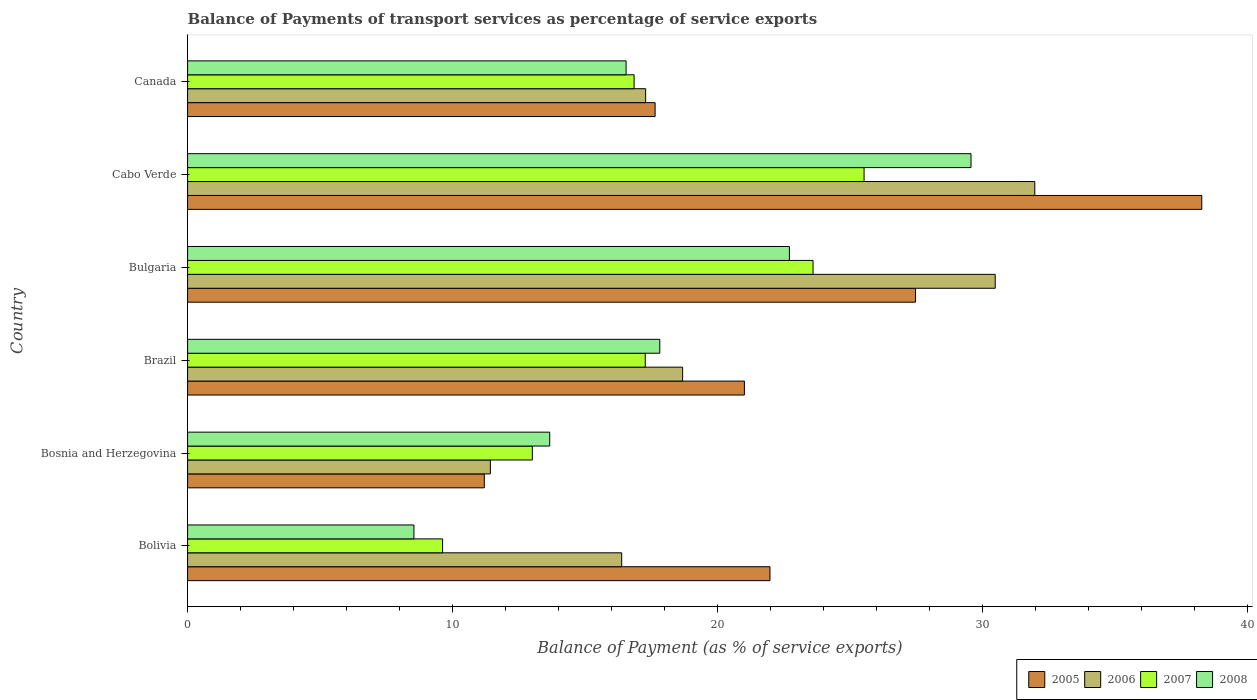Are the number of bars per tick equal to the number of legend labels?
Make the answer very short. Yes. How many bars are there on the 3rd tick from the bottom?
Your answer should be very brief. 4. What is the label of the 5th group of bars from the top?
Provide a short and direct response. Bosnia and Herzegovina. What is the balance of payments of transport services in 2008 in Bolivia?
Make the answer very short. 8.54. Across all countries, what is the maximum balance of payments of transport services in 2006?
Offer a very short reply. 31.97. Across all countries, what is the minimum balance of payments of transport services in 2007?
Provide a short and direct response. 9.62. In which country was the balance of payments of transport services in 2005 maximum?
Give a very brief answer. Cabo Verde. In which country was the balance of payments of transport services in 2006 minimum?
Your answer should be very brief. Bosnia and Herzegovina. What is the total balance of payments of transport services in 2007 in the graph?
Your response must be concise. 105.87. What is the difference between the balance of payments of transport services in 2007 in Bolivia and that in Bosnia and Herzegovina?
Your answer should be very brief. -3.39. What is the difference between the balance of payments of transport services in 2008 in Cabo Verde and the balance of payments of transport services in 2006 in Bosnia and Herzegovina?
Your answer should be compact. 18.14. What is the average balance of payments of transport services in 2006 per country?
Your answer should be very brief. 21.03. What is the difference between the balance of payments of transport services in 2005 and balance of payments of transport services in 2008 in Cabo Verde?
Provide a short and direct response. 8.71. In how many countries, is the balance of payments of transport services in 2007 greater than 14 %?
Your answer should be very brief. 4. What is the ratio of the balance of payments of transport services in 2008 in Bolivia to that in Canada?
Your answer should be very brief. 0.52. Is the balance of payments of transport services in 2008 in Brazil less than that in Cabo Verde?
Your response must be concise. Yes. Is the difference between the balance of payments of transport services in 2005 in Bosnia and Herzegovina and Canada greater than the difference between the balance of payments of transport services in 2008 in Bosnia and Herzegovina and Canada?
Ensure brevity in your answer.  No. What is the difference between the highest and the second highest balance of payments of transport services in 2005?
Your answer should be very brief. 10.8. What is the difference between the highest and the lowest balance of payments of transport services in 2005?
Ensure brevity in your answer.  27.07. Is it the case that in every country, the sum of the balance of payments of transport services in 2007 and balance of payments of transport services in 2006 is greater than the sum of balance of payments of transport services in 2008 and balance of payments of transport services in 2005?
Ensure brevity in your answer.  No. What is the difference between two consecutive major ticks on the X-axis?
Offer a terse response. 10. Are the values on the major ticks of X-axis written in scientific E-notation?
Ensure brevity in your answer.  No. Where does the legend appear in the graph?
Give a very brief answer. Bottom right. How many legend labels are there?
Ensure brevity in your answer.  4. What is the title of the graph?
Make the answer very short. Balance of Payments of transport services as percentage of service exports. Does "1972" appear as one of the legend labels in the graph?
Your answer should be compact. No. What is the label or title of the X-axis?
Provide a short and direct response. Balance of Payment (as % of service exports). What is the Balance of Payment (as % of service exports) in 2005 in Bolivia?
Offer a very short reply. 21.97. What is the Balance of Payment (as % of service exports) of 2006 in Bolivia?
Your answer should be very brief. 16.38. What is the Balance of Payment (as % of service exports) of 2007 in Bolivia?
Your answer should be very brief. 9.62. What is the Balance of Payment (as % of service exports) of 2008 in Bolivia?
Provide a succinct answer. 8.54. What is the Balance of Payment (as % of service exports) of 2005 in Bosnia and Herzegovina?
Keep it short and to the point. 11.19. What is the Balance of Payment (as % of service exports) of 2006 in Bosnia and Herzegovina?
Provide a succinct answer. 11.42. What is the Balance of Payment (as % of service exports) of 2007 in Bosnia and Herzegovina?
Offer a terse response. 13.01. What is the Balance of Payment (as % of service exports) in 2008 in Bosnia and Herzegovina?
Make the answer very short. 13.66. What is the Balance of Payment (as % of service exports) in 2005 in Brazil?
Offer a very short reply. 21.01. What is the Balance of Payment (as % of service exports) in 2006 in Brazil?
Your answer should be very brief. 18.68. What is the Balance of Payment (as % of service exports) in 2007 in Brazil?
Provide a short and direct response. 17.27. What is the Balance of Payment (as % of service exports) in 2008 in Brazil?
Your answer should be very brief. 17.82. What is the Balance of Payment (as % of service exports) in 2005 in Bulgaria?
Provide a short and direct response. 27.47. What is the Balance of Payment (as % of service exports) in 2006 in Bulgaria?
Your response must be concise. 30.47. What is the Balance of Payment (as % of service exports) in 2007 in Bulgaria?
Your response must be concise. 23.6. What is the Balance of Payment (as % of service exports) of 2008 in Bulgaria?
Offer a terse response. 22.71. What is the Balance of Payment (as % of service exports) in 2005 in Cabo Verde?
Your answer should be compact. 38.27. What is the Balance of Payment (as % of service exports) of 2006 in Cabo Verde?
Give a very brief answer. 31.97. What is the Balance of Payment (as % of service exports) of 2007 in Cabo Verde?
Give a very brief answer. 25.53. What is the Balance of Payment (as % of service exports) in 2008 in Cabo Verde?
Provide a succinct answer. 29.56. What is the Balance of Payment (as % of service exports) in 2005 in Canada?
Make the answer very short. 17.64. What is the Balance of Payment (as % of service exports) of 2006 in Canada?
Give a very brief answer. 17.28. What is the Balance of Payment (as % of service exports) of 2007 in Canada?
Offer a very short reply. 16.85. What is the Balance of Payment (as % of service exports) in 2008 in Canada?
Give a very brief answer. 16.55. Across all countries, what is the maximum Balance of Payment (as % of service exports) of 2005?
Your answer should be compact. 38.27. Across all countries, what is the maximum Balance of Payment (as % of service exports) of 2006?
Provide a short and direct response. 31.97. Across all countries, what is the maximum Balance of Payment (as % of service exports) of 2007?
Your answer should be compact. 25.53. Across all countries, what is the maximum Balance of Payment (as % of service exports) in 2008?
Provide a short and direct response. 29.56. Across all countries, what is the minimum Balance of Payment (as % of service exports) in 2005?
Give a very brief answer. 11.19. Across all countries, what is the minimum Balance of Payment (as % of service exports) in 2006?
Provide a short and direct response. 11.42. Across all countries, what is the minimum Balance of Payment (as % of service exports) in 2007?
Your answer should be very brief. 9.62. Across all countries, what is the minimum Balance of Payment (as % of service exports) of 2008?
Offer a very short reply. 8.54. What is the total Balance of Payment (as % of service exports) of 2005 in the graph?
Give a very brief answer. 137.55. What is the total Balance of Payment (as % of service exports) in 2006 in the graph?
Give a very brief answer. 126.21. What is the total Balance of Payment (as % of service exports) of 2007 in the graph?
Offer a terse response. 105.87. What is the total Balance of Payment (as % of service exports) in 2008 in the graph?
Offer a terse response. 108.83. What is the difference between the Balance of Payment (as % of service exports) of 2005 in Bolivia and that in Bosnia and Herzegovina?
Make the answer very short. 10.78. What is the difference between the Balance of Payment (as % of service exports) in 2006 in Bolivia and that in Bosnia and Herzegovina?
Your answer should be very brief. 4.96. What is the difference between the Balance of Payment (as % of service exports) of 2007 in Bolivia and that in Bosnia and Herzegovina?
Your response must be concise. -3.39. What is the difference between the Balance of Payment (as % of service exports) of 2008 in Bolivia and that in Bosnia and Herzegovina?
Give a very brief answer. -5.12. What is the difference between the Balance of Payment (as % of service exports) in 2005 in Bolivia and that in Brazil?
Your response must be concise. 0.97. What is the difference between the Balance of Payment (as % of service exports) of 2006 in Bolivia and that in Brazil?
Your answer should be compact. -2.3. What is the difference between the Balance of Payment (as % of service exports) in 2007 in Bolivia and that in Brazil?
Provide a short and direct response. -7.65. What is the difference between the Balance of Payment (as % of service exports) in 2008 in Bolivia and that in Brazil?
Ensure brevity in your answer.  -9.28. What is the difference between the Balance of Payment (as % of service exports) of 2005 in Bolivia and that in Bulgaria?
Your answer should be compact. -5.49. What is the difference between the Balance of Payment (as % of service exports) in 2006 in Bolivia and that in Bulgaria?
Your answer should be compact. -14.09. What is the difference between the Balance of Payment (as % of service exports) of 2007 in Bolivia and that in Bulgaria?
Your answer should be very brief. -13.98. What is the difference between the Balance of Payment (as % of service exports) in 2008 in Bolivia and that in Bulgaria?
Give a very brief answer. -14.17. What is the difference between the Balance of Payment (as % of service exports) of 2005 in Bolivia and that in Cabo Verde?
Offer a terse response. -16.29. What is the difference between the Balance of Payment (as % of service exports) in 2006 in Bolivia and that in Cabo Verde?
Give a very brief answer. -15.59. What is the difference between the Balance of Payment (as % of service exports) in 2007 in Bolivia and that in Cabo Verde?
Ensure brevity in your answer.  -15.9. What is the difference between the Balance of Payment (as % of service exports) of 2008 in Bolivia and that in Cabo Verde?
Your answer should be very brief. -21.02. What is the difference between the Balance of Payment (as % of service exports) of 2005 in Bolivia and that in Canada?
Ensure brevity in your answer.  4.33. What is the difference between the Balance of Payment (as % of service exports) of 2006 in Bolivia and that in Canada?
Keep it short and to the point. -0.9. What is the difference between the Balance of Payment (as % of service exports) in 2007 in Bolivia and that in Canada?
Provide a succinct answer. -7.23. What is the difference between the Balance of Payment (as % of service exports) of 2008 in Bolivia and that in Canada?
Keep it short and to the point. -8.01. What is the difference between the Balance of Payment (as % of service exports) in 2005 in Bosnia and Herzegovina and that in Brazil?
Offer a very short reply. -9.81. What is the difference between the Balance of Payment (as % of service exports) in 2006 in Bosnia and Herzegovina and that in Brazil?
Your answer should be compact. -7.25. What is the difference between the Balance of Payment (as % of service exports) of 2007 in Bosnia and Herzegovina and that in Brazil?
Offer a very short reply. -4.26. What is the difference between the Balance of Payment (as % of service exports) of 2008 in Bosnia and Herzegovina and that in Brazil?
Make the answer very short. -4.15. What is the difference between the Balance of Payment (as % of service exports) in 2005 in Bosnia and Herzegovina and that in Bulgaria?
Your answer should be compact. -16.27. What is the difference between the Balance of Payment (as % of service exports) of 2006 in Bosnia and Herzegovina and that in Bulgaria?
Offer a terse response. -19.05. What is the difference between the Balance of Payment (as % of service exports) of 2007 in Bosnia and Herzegovina and that in Bulgaria?
Your answer should be very brief. -10.59. What is the difference between the Balance of Payment (as % of service exports) of 2008 in Bosnia and Herzegovina and that in Bulgaria?
Your response must be concise. -9.04. What is the difference between the Balance of Payment (as % of service exports) in 2005 in Bosnia and Herzegovina and that in Cabo Verde?
Provide a succinct answer. -27.07. What is the difference between the Balance of Payment (as % of service exports) in 2006 in Bosnia and Herzegovina and that in Cabo Verde?
Give a very brief answer. -20.54. What is the difference between the Balance of Payment (as % of service exports) in 2007 in Bosnia and Herzegovina and that in Cabo Verde?
Your response must be concise. -12.52. What is the difference between the Balance of Payment (as % of service exports) in 2008 in Bosnia and Herzegovina and that in Cabo Verde?
Provide a succinct answer. -15.9. What is the difference between the Balance of Payment (as % of service exports) of 2005 in Bosnia and Herzegovina and that in Canada?
Your answer should be compact. -6.45. What is the difference between the Balance of Payment (as % of service exports) in 2006 in Bosnia and Herzegovina and that in Canada?
Your response must be concise. -5.86. What is the difference between the Balance of Payment (as % of service exports) of 2007 in Bosnia and Herzegovina and that in Canada?
Your answer should be compact. -3.84. What is the difference between the Balance of Payment (as % of service exports) in 2008 in Bosnia and Herzegovina and that in Canada?
Offer a terse response. -2.88. What is the difference between the Balance of Payment (as % of service exports) in 2005 in Brazil and that in Bulgaria?
Your answer should be compact. -6.46. What is the difference between the Balance of Payment (as % of service exports) in 2006 in Brazil and that in Bulgaria?
Your response must be concise. -11.79. What is the difference between the Balance of Payment (as % of service exports) in 2007 in Brazil and that in Bulgaria?
Ensure brevity in your answer.  -6.33. What is the difference between the Balance of Payment (as % of service exports) in 2008 in Brazil and that in Bulgaria?
Ensure brevity in your answer.  -4.89. What is the difference between the Balance of Payment (as % of service exports) of 2005 in Brazil and that in Cabo Verde?
Give a very brief answer. -17.26. What is the difference between the Balance of Payment (as % of service exports) of 2006 in Brazil and that in Cabo Verde?
Offer a very short reply. -13.29. What is the difference between the Balance of Payment (as % of service exports) of 2007 in Brazil and that in Cabo Verde?
Ensure brevity in your answer.  -8.26. What is the difference between the Balance of Payment (as % of service exports) in 2008 in Brazil and that in Cabo Verde?
Your answer should be compact. -11.74. What is the difference between the Balance of Payment (as % of service exports) in 2005 in Brazil and that in Canada?
Your answer should be very brief. 3.37. What is the difference between the Balance of Payment (as % of service exports) in 2006 in Brazil and that in Canada?
Your answer should be very brief. 1.39. What is the difference between the Balance of Payment (as % of service exports) in 2007 in Brazil and that in Canada?
Keep it short and to the point. 0.42. What is the difference between the Balance of Payment (as % of service exports) of 2008 in Brazil and that in Canada?
Your answer should be compact. 1.27. What is the difference between the Balance of Payment (as % of service exports) in 2005 in Bulgaria and that in Cabo Verde?
Make the answer very short. -10.8. What is the difference between the Balance of Payment (as % of service exports) of 2006 in Bulgaria and that in Cabo Verde?
Give a very brief answer. -1.49. What is the difference between the Balance of Payment (as % of service exports) in 2007 in Bulgaria and that in Cabo Verde?
Offer a very short reply. -1.93. What is the difference between the Balance of Payment (as % of service exports) in 2008 in Bulgaria and that in Cabo Verde?
Ensure brevity in your answer.  -6.85. What is the difference between the Balance of Payment (as % of service exports) in 2005 in Bulgaria and that in Canada?
Your answer should be very brief. 9.83. What is the difference between the Balance of Payment (as % of service exports) of 2006 in Bulgaria and that in Canada?
Your answer should be very brief. 13.19. What is the difference between the Balance of Payment (as % of service exports) of 2007 in Bulgaria and that in Canada?
Offer a terse response. 6.75. What is the difference between the Balance of Payment (as % of service exports) of 2008 in Bulgaria and that in Canada?
Ensure brevity in your answer.  6.16. What is the difference between the Balance of Payment (as % of service exports) in 2005 in Cabo Verde and that in Canada?
Your answer should be compact. 20.63. What is the difference between the Balance of Payment (as % of service exports) in 2006 in Cabo Verde and that in Canada?
Make the answer very short. 14.68. What is the difference between the Balance of Payment (as % of service exports) in 2007 in Cabo Verde and that in Canada?
Give a very brief answer. 8.68. What is the difference between the Balance of Payment (as % of service exports) of 2008 in Cabo Verde and that in Canada?
Make the answer very short. 13.01. What is the difference between the Balance of Payment (as % of service exports) in 2005 in Bolivia and the Balance of Payment (as % of service exports) in 2006 in Bosnia and Herzegovina?
Keep it short and to the point. 10.55. What is the difference between the Balance of Payment (as % of service exports) of 2005 in Bolivia and the Balance of Payment (as % of service exports) of 2007 in Bosnia and Herzegovina?
Provide a succinct answer. 8.97. What is the difference between the Balance of Payment (as % of service exports) in 2005 in Bolivia and the Balance of Payment (as % of service exports) in 2008 in Bosnia and Herzegovina?
Offer a very short reply. 8.31. What is the difference between the Balance of Payment (as % of service exports) of 2006 in Bolivia and the Balance of Payment (as % of service exports) of 2007 in Bosnia and Herzegovina?
Give a very brief answer. 3.37. What is the difference between the Balance of Payment (as % of service exports) of 2006 in Bolivia and the Balance of Payment (as % of service exports) of 2008 in Bosnia and Herzegovina?
Give a very brief answer. 2.72. What is the difference between the Balance of Payment (as % of service exports) of 2007 in Bolivia and the Balance of Payment (as % of service exports) of 2008 in Bosnia and Herzegovina?
Give a very brief answer. -4.04. What is the difference between the Balance of Payment (as % of service exports) in 2005 in Bolivia and the Balance of Payment (as % of service exports) in 2006 in Brazil?
Your response must be concise. 3.3. What is the difference between the Balance of Payment (as % of service exports) in 2005 in Bolivia and the Balance of Payment (as % of service exports) in 2007 in Brazil?
Your answer should be very brief. 4.71. What is the difference between the Balance of Payment (as % of service exports) in 2005 in Bolivia and the Balance of Payment (as % of service exports) in 2008 in Brazil?
Your response must be concise. 4.16. What is the difference between the Balance of Payment (as % of service exports) in 2006 in Bolivia and the Balance of Payment (as % of service exports) in 2007 in Brazil?
Give a very brief answer. -0.89. What is the difference between the Balance of Payment (as % of service exports) in 2006 in Bolivia and the Balance of Payment (as % of service exports) in 2008 in Brazil?
Keep it short and to the point. -1.44. What is the difference between the Balance of Payment (as % of service exports) of 2007 in Bolivia and the Balance of Payment (as % of service exports) of 2008 in Brazil?
Ensure brevity in your answer.  -8.2. What is the difference between the Balance of Payment (as % of service exports) of 2005 in Bolivia and the Balance of Payment (as % of service exports) of 2006 in Bulgaria?
Make the answer very short. -8.5. What is the difference between the Balance of Payment (as % of service exports) in 2005 in Bolivia and the Balance of Payment (as % of service exports) in 2007 in Bulgaria?
Ensure brevity in your answer.  -1.62. What is the difference between the Balance of Payment (as % of service exports) in 2005 in Bolivia and the Balance of Payment (as % of service exports) in 2008 in Bulgaria?
Your response must be concise. -0.73. What is the difference between the Balance of Payment (as % of service exports) of 2006 in Bolivia and the Balance of Payment (as % of service exports) of 2007 in Bulgaria?
Provide a short and direct response. -7.22. What is the difference between the Balance of Payment (as % of service exports) of 2006 in Bolivia and the Balance of Payment (as % of service exports) of 2008 in Bulgaria?
Provide a succinct answer. -6.33. What is the difference between the Balance of Payment (as % of service exports) of 2007 in Bolivia and the Balance of Payment (as % of service exports) of 2008 in Bulgaria?
Keep it short and to the point. -13.09. What is the difference between the Balance of Payment (as % of service exports) in 2005 in Bolivia and the Balance of Payment (as % of service exports) in 2006 in Cabo Verde?
Your answer should be very brief. -9.99. What is the difference between the Balance of Payment (as % of service exports) in 2005 in Bolivia and the Balance of Payment (as % of service exports) in 2007 in Cabo Verde?
Keep it short and to the point. -3.55. What is the difference between the Balance of Payment (as % of service exports) of 2005 in Bolivia and the Balance of Payment (as % of service exports) of 2008 in Cabo Verde?
Offer a very short reply. -7.58. What is the difference between the Balance of Payment (as % of service exports) of 2006 in Bolivia and the Balance of Payment (as % of service exports) of 2007 in Cabo Verde?
Provide a short and direct response. -9.15. What is the difference between the Balance of Payment (as % of service exports) of 2006 in Bolivia and the Balance of Payment (as % of service exports) of 2008 in Cabo Verde?
Provide a succinct answer. -13.18. What is the difference between the Balance of Payment (as % of service exports) of 2007 in Bolivia and the Balance of Payment (as % of service exports) of 2008 in Cabo Verde?
Give a very brief answer. -19.94. What is the difference between the Balance of Payment (as % of service exports) in 2005 in Bolivia and the Balance of Payment (as % of service exports) in 2006 in Canada?
Keep it short and to the point. 4.69. What is the difference between the Balance of Payment (as % of service exports) in 2005 in Bolivia and the Balance of Payment (as % of service exports) in 2007 in Canada?
Provide a succinct answer. 5.13. What is the difference between the Balance of Payment (as % of service exports) in 2005 in Bolivia and the Balance of Payment (as % of service exports) in 2008 in Canada?
Ensure brevity in your answer.  5.43. What is the difference between the Balance of Payment (as % of service exports) in 2006 in Bolivia and the Balance of Payment (as % of service exports) in 2007 in Canada?
Give a very brief answer. -0.47. What is the difference between the Balance of Payment (as % of service exports) in 2006 in Bolivia and the Balance of Payment (as % of service exports) in 2008 in Canada?
Provide a succinct answer. -0.17. What is the difference between the Balance of Payment (as % of service exports) of 2007 in Bolivia and the Balance of Payment (as % of service exports) of 2008 in Canada?
Your answer should be very brief. -6.92. What is the difference between the Balance of Payment (as % of service exports) in 2005 in Bosnia and Herzegovina and the Balance of Payment (as % of service exports) in 2006 in Brazil?
Your answer should be very brief. -7.48. What is the difference between the Balance of Payment (as % of service exports) of 2005 in Bosnia and Herzegovina and the Balance of Payment (as % of service exports) of 2007 in Brazil?
Offer a very short reply. -6.07. What is the difference between the Balance of Payment (as % of service exports) in 2005 in Bosnia and Herzegovina and the Balance of Payment (as % of service exports) in 2008 in Brazil?
Ensure brevity in your answer.  -6.62. What is the difference between the Balance of Payment (as % of service exports) in 2006 in Bosnia and Herzegovina and the Balance of Payment (as % of service exports) in 2007 in Brazil?
Offer a terse response. -5.84. What is the difference between the Balance of Payment (as % of service exports) in 2006 in Bosnia and Herzegovina and the Balance of Payment (as % of service exports) in 2008 in Brazil?
Your response must be concise. -6.39. What is the difference between the Balance of Payment (as % of service exports) in 2007 in Bosnia and Herzegovina and the Balance of Payment (as % of service exports) in 2008 in Brazil?
Give a very brief answer. -4.81. What is the difference between the Balance of Payment (as % of service exports) in 2005 in Bosnia and Herzegovina and the Balance of Payment (as % of service exports) in 2006 in Bulgaria?
Provide a succinct answer. -19.28. What is the difference between the Balance of Payment (as % of service exports) in 2005 in Bosnia and Herzegovina and the Balance of Payment (as % of service exports) in 2007 in Bulgaria?
Offer a very short reply. -12.4. What is the difference between the Balance of Payment (as % of service exports) in 2005 in Bosnia and Herzegovina and the Balance of Payment (as % of service exports) in 2008 in Bulgaria?
Provide a short and direct response. -11.51. What is the difference between the Balance of Payment (as % of service exports) of 2006 in Bosnia and Herzegovina and the Balance of Payment (as % of service exports) of 2007 in Bulgaria?
Make the answer very short. -12.18. What is the difference between the Balance of Payment (as % of service exports) in 2006 in Bosnia and Herzegovina and the Balance of Payment (as % of service exports) in 2008 in Bulgaria?
Your answer should be very brief. -11.28. What is the difference between the Balance of Payment (as % of service exports) in 2007 in Bosnia and Herzegovina and the Balance of Payment (as % of service exports) in 2008 in Bulgaria?
Offer a very short reply. -9.7. What is the difference between the Balance of Payment (as % of service exports) in 2005 in Bosnia and Herzegovina and the Balance of Payment (as % of service exports) in 2006 in Cabo Verde?
Your answer should be very brief. -20.77. What is the difference between the Balance of Payment (as % of service exports) of 2005 in Bosnia and Herzegovina and the Balance of Payment (as % of service exports) of 2007 in Cabo Verde?
Your answer should be compact. -14.33. What is the difference between the Balance of Payment (as % of service exports) of 2005 in Bosnia and Herzegovina and the Balance of Payment (as % of service exports) of 2008 in Cabo Verde?
Ensure brevity in your answer.  -18.36. What is the difference between the Balance of Payment (as % of service exports) of 2006 in Bosnia and Herzegovina and the Balance of Payment (as % of service exports) of 2007 in Cabo Verde?
Provide a succinct answer. -14.1. What is the difference between the Balance of Payment (as % of service exports) of 2006 in Bosnia and Herzegovina and the Balance of Payment (as % of service exports) of 2008 in Cabo Verde?
Offer a terse response. -18.14. What is the difference between the Balance of Payment (as % of service exports) in 2007 in Bosnia and Herzegovina and the Balance of Payment (as % of service exports) in 2008 in Cabo Verde?
Your answer should be very brief. -16.55. What is the difference between the Balance of Payment (as % of service exports) in 2005 in Bosnia and Herzegovina and the Balance of Payment (as % of service exports) in 2006 in Canada?
Your answer should be very brief. -6.09. What is the difference between the Balance of Payment (as % of service exports) of 2005 in Bosnia and Herzegovina and the Balance of Payment (as % of service exports) of 2007 in Canada?
Provide a succinct answer. -5.65. What is the difference between the Balance of Payment (as % of service exports) of 2005 in Bosnia and Herzegovina and the Balance of Payment (as % of service exports) of 2008 in Canada?
Your answer should be very brief. -5.35. What is the difference between the Balance of Payment (as % of service exports) in 2006 in Bosnia and Herzegovina and the Balance of Payment (as % of service exports) in 2007 in Canada?
Offer a terse response. -5.42. What is the difference between the Balance of Payment (as % of service exports) in 2006 in Bosnia and Herzegovina and the Balance of Payment (as % of service exports) in 2008 in Canada?
Offer a very short reply. -5.12. What is the difference between the Balance of Payment (as % of service exports) of 2007 in Bosnia and Herzegovina and the Balance of Payment (as % of service exports) of 2008 in Canada?
Provide a succinct answer. -3.54. What is the difference between the Balance of Payment (as % of service exports) in 2005 in Brazil and the Balance of Payment (as % of service exports) in 2006 in Bulgaria?
Ensure brevity in your answer.  -9.46. What is the difference between the Balance of Payment (as % of service exports) in 2005 in Brazil and the Balance of Payment (as % of service exports) in 2007 in Bulgaria?
Offer a very short reply. -2.59. What is the difference between the Balance of Payment (as % of service exports) of 2005 in Brazil and the Balance of Payment (as % of service exports) of 2008 in Bulgaria?
Offer a terse response. -1.7. What is the difference between the Balance of Payment (as % of service exports) of 2006 in Brazil and the Balance of Payment (as % of service exports) of 2007 in Bulgaria?
Your answer should be very brief. -4.92. What is the difference between the Balance of Payment (as % of service exports) of 2006 in Brazil and the Balance of Payment (as % of service exports) of 2008 in Bulgaria?
Offer a terse response. -4.03. What is the difference between the Balance of Payment (as % of service exports) of 2007 in Brazil and the Balance of Payment (as % of service exports) of 2008 in Bulgaria?
Your response must be concise. -5.44. What is the difference between the Balance of Payment (as % of service exports) in 2005 in Brazil and the Balance of Payment (as % of service exports) in 2006 in Cabo Verde?
Make the answer very short. -10.96. What is the difference between the Balance of Payment (as % of service exports) in 2005 in Brazil and the Balance of Payment (as % of service exports) in 2007 in Cabo Verde?
Provide a succinct answer. -4.52. What is the difference between the Balance of Payment (as % of service exports) of 2005 in Brazil and the Balance of Payment (as % of service exports) of 2008 in Cabo Verde?
Provide a succinct answer. -8.55. What is the difference between the Balance of Payment (as % of service exports) of 2006 in Brazil and the Balance of Payment (as % of service exports) of 2007 in Cabo Verde?
Provide a short and direct response. -6.85. What is the difference between the Balance of Payment (as % of service exports) in 2006 in Brazil and the Balance of Payment (as % of service exports) in 2008 in Cabo Verde?
Offer a very short reply. -10.88. What is the difference between the Balance of Payment (as % of service exports) in 2007 in Brazil and the Balance of Payment (as % of service exports) in 2008 in Cabo Verde?
Ensure brevity in your answer.  -12.29. What is the difference between the Balance of Payment (as % of service exports) of 2005 in Brazil and the Balance of Payment (as % of service exports) of 2006 in Canada?
Keep it short and to the point. 3.73. What is the difference between the Balance of Payment (as % of service exports) of 2005 in Brazil and the Balance of Payment (as % of service exports) of 2007 in Canada?
Ensure brevity in your answer.  4.16. What is the difference between the Balance of Payment (as % of service exports) in 2005 in Brazil and the Balance of Payment (as % of service exports) in 2008 in Canada?
Keep it short and to the point. 4.46. What is the difference between the Balance of Payment (as % of service exports) of 2006 in Brazil and the Balance of Payment (as % of service exports) of 2007 in Canada?
Provide a succinct answer. 1.83. What is the difference between the Balance of Payment (as % of service exports) of 2006 in Brazil and the Balance of Payment (as % of service exports) of 2008 in Canada?
Give a very brief answer. 2.13. What is the difference between the Balance of Payment (as % of service exports) of 2007 in Brazil and the Balance of Payment (as % of service exports) of 2008 in Canada?
Offer a terse response. 0.72. What is the difference between the Balance of Payment (as % of service exports) in 2005 in Bulgaria and the Balance of Payment (as % of service exports) in 2006 in Cabo Verde?
Make the answer very short. -4.5. What is the difference between the Balance of Payment (as % of service exports) of 2005 in Bulgaria and the Balance of Payment (as % of service exports) of 2007 in Cabo Verde?
Offer a terse response. 1.94. What is the difference between the Balance of Payment (as % of service exports) in 2005 in Bulgaria and the Balance of Payment (as % of service exports) in 2008 in Cabo Verde?
Keep it short and to the point. -2.09. What is the difference between the Balance of Payment (as % of service exports) in 2006 in Bulgaria and the Balance of Payment (as % of service exports) in 2007 in Cabo Verde?
Your answer should be very brief. 4.95. What is the difference between the Balance of Payment (as % of service exports) of 2006 in Bulgaria and the Balance of Payment (as % of service exports) of 2008 in Cabo Verde?
Your response must be concise. 0.91. What is the difference between the Balance of Payment (as % of service exports) of 2007 in Bulgaria and the Balance of Payment (as % of service exports) of 2008 in Cabo Verde?
Provide a succinct answer. -5.96. What is the difference between the Balance of Payment (as % of service exports) in 2005 in Bulgaria and the Balance of Payment (as % of service exports) in 2006 in Canada?
Ensure brevity in your answer.  10.18. What is the difference between the Balance of Payment (as % of service exports) of 2005 in Bulgaria and the Balance of Payment (as % of service exports) of 2007 in Canada?
Your response must be concise. 10.62. What is the difference between the Balance of Payment (as % of service exports) in 2005 in Bulgaria and the Balance of Payment (as % of service exports) in 2008 in Canada?
Provide a short and direct response. 10.92. What is the difference between the Balance of Payment (as % of service exports) in 2006 in Bulgaria and the Balance of Payment (as % of service exports) in 2007 in Canada?
Keep it short and to the point. 13.63. What is the difference between the Balance of Payment (as % of service exports) of 2006 in Bulgaria and the Balance of Payment (as % of service exports) of 2008 in Canada?
Keep it short and to the point. 13.93. What is the difference between the Balance of Payment (as % of service exports) of 2007 in Bulgaria and the Balance of Payment (as % of service exports) of 2008 in Canada?
Your response must be concise. 7.05. What is the difference between the Balance of Payment (as % of service exports) in 2005 in Cabo Verde and the Balance of Payment (as % of service exports) in 2006 in Canada?
Provide a short and direct response. 20.98. What is the difference between the Balance of Payment (as % of service exports) of 2005 in Cabo Verde and the Balance of Payment (as % of service exports) of 2007 in Canada?
Provide a short and direct response. 21.42. What is the difference between the Balance of Payment (as % of service exports) in 2005 in Cabo Verde and the Balance of Payment (as % of service exports) in 2008 in Canada?
Provide a succinct answer. 21.72. What is the difference between the Balance of Payment (as % of service exports) of 2006 in Cabo Verde and the Balance of Payment (as % of service exports) of 2007 in Canada?
Offer a terse response. 15.12. What is the difference between the Balance of Payment (as % of service exports) of 2006 in Cabo Verde and the Balance of Payment (as % of service exports) of 2008 in Canada?
Offer a very short reply. 15.42. What is the difference between the Balance of Payment (as % of service exports) of 2007 in Cabo Verde and the Balance of Payment (as % of service exports) of 2008 in Canada?
Keep it short and to the point. 8.98. What is the average Balance of Payment (as % of service exports) of 2005 per country?
Your answer should be compact. 22.93. What is the average Balance of Payment (as % of service exports) of 2006 per country?
Your answer should be compact. 21.03. What is the average Balance of Payment (as % of service exports) in 2007 per country?
Your response must be concise. 17.64. What is the average Balance of Payment (as % of service exports) in 2008 per country?
Offer a terse response. 18.14. What is the difference between the Balance of Payment (as % of service exports) of 2005 and Balance of Payment (as % of service exports) of 2006 in Bolivia?
Keep it short and to the point. 5.59. What is the difference between the Balance of Payment (as % of service exports) in 2005 and Balance of Payment (as % of service exports) in 2007 in Bolivia?
Provide a succinct answer. 12.35. What is the difference between the Balance of Payment (as % of service exports) of 2005 and Balance of Payment (as % of service exports) of 2008 in Bolivia?
Ensure brevity in your answer.  13.43. What is the difference between the Balance of Payment (as % of service exports) in 2006 and Balance of Payment (as % of service exports) in 2007 in Bolivia?
Offer a very short reply. 6.76. What is the difference between the Balance of Payment (as % of service exports) of 2006 and Balance of Payment (as % of service exports) of 2008 in Bolivia?
Your answer should be very brief. 7.84. What is the difference between the Balance of Payment (as % of service exports) in 2007 and Balance of Payment (as % of service exports) in 2008 in Bolivia?
Give a very brief answer. 1.08. What is the difference between the Balance of Payment (as % of service exports) in 2005 and Balance of Payment (as % of service exports) in 2006 in Bosnia and Herzegovina?
Offer a very short reply. -0.23. What is the difference between the Balance of Payment (as % of service exports) of 2005 and Balance of Payment (as % of service exports) of 2007 in Bosnia and Herzegovina?
Provide a succinct answer. -1.81. What is the difference between the Balance of Payment (as % of service exports) in 2005 and Balance of Payment (as % of service exports) in 2008 in Bosnia and Herzegovina?
Make the answer very short. -2.47. What is the difference between the Balance of Payment (as % of service exports) in 2006 and Balance of Payment (as % of service exports) in 2007 in Bosnia and Herzegovina?
Keep it short and to the point. -1.58. What is the difference between the Balance of Payment (as % of service exports) of 2006 and Balance of Payment (as % of service exports) of 2008 in Bosnia and Herzegovina?
Provide a short and direct response. -2.24. What is the difference between the Balance of Payment (as % of service exports) in 2007 and Balance of Payment (as % of service exports) in 2008 in Bosnia and Herzegovina?
Ensure brevity in your answer.  -0.66. What is the difference between the Balance of Payment (as % of service exports) in 2005 and Balance of Payment (as % of service exports) in 2006 in Brazil?
Your answer should be very brief. 2.33. What is the difference between the Balance of Payment (as % of service exports) of 2005 and Balance of Payment (as % of service exports) of 2007 in Brazil?
Make the answer very short. 3.74. What is the difference between the Balance of Payment (as % of service exports) in 2005 and Balance of Payment (as % of service exports) in 2008 in Brazil?
Make the answer very short. 3.19. What is the difference between the Balance of Payment (as % of service exports) in 2006 and Balance of Payment (as % of service exports) in 2007 in Brazil?
Offer a very short reply. 1.41. What is the difference between the Balance of Payment (as % of service exports) in 2006 and Balance of Payment (as % of service exports) in 2008 in Brazil?
Your answer should be very brief. 0.86. What is the difference between the Balance of Payment (as % of service exports) in 2007 and Balance of Payment (as % of service exports) in 2008 in Brazil?
Keep it short and to the point. -0.55. What is the difference between the Balance of Payment (as % of service exports) of 2005 and Balance of Payment (as % of service exports) of 2006 in Bulgaria?
Make the answer very short. -3.01. What is the difference between the Balance of Payment (as % of service exports) in 2005 and Balance of Payment (as % of service exports) in 2007 in Bulgaria?
Offer a terse response. 3.87. What is the difference between the Balance of Payment (as % of service exports) of 2005 and Balance of Payment (as % of service exports) of 2008 in Bulgaria?
Keep it short and to the point. 4.76. What is the difference between the Balance of Payment (as % of service exports) in 2006 and Balance of Payment (as % of service exports) in 2007 in Bulgaria?
Make the answer very short. 6.87. What is the difference between the Balance of Payment (as % of service exports) of 2006 and Balance of Payment (as % of service exports) of 2008 in Bulgaria?
Your answer should be very brief. 7.77. What is the difference between the Balance of Payment (as % of service exports) in 2007 and Balance of Payment (as % of service exports) in 2008 in Bulgaria?
Keep it short and to the point. 0.89. What is the difference between the Balance of Payment (as % of service exports) in 2005 and Balance of Payment (as % of service exports) in 2006 in Cabo Verde?
Your answer should be compact. 6.3. What is the difference between the Balance of Payment (as % of service exports) of 2005 and Balance of Payment (as % of service exports) of 2007 in Cabo Verde?
Offer a very short reply. 12.74. What is the difference between the Balance of Payment (as % of service exports) of 2005 and Balance of Payment (as % of service exports) of 2008 in Cabo Verde?
Ensure brevity in your answer.  8.71. What is the difference between the Balance of Payment (as % of service exports) in 2006 and Balance of Payment (as % of service exports) in 2007 in Cabo Verde?
Give a very brief answer. 6.44. What is the difference between the Balance of Payment (as % of service exports) in 2006 and Balance of Payment (as % of service exports) in 2008 in Cabo Verde?
Provide a short and direct response. 2.41. What is the difference between the Balance of Payment (as % of service exports) of 2007 and Balance of Payment (as % of service exports) of 2008 in Cabo Verde?
Offer a very short reply. -4.03. What is the difference between the Balance of Payment (as % of service exports) of 2005 and Balance of Payment (as % of service exports) of 2006 in Canada?
Offer a terse response. 0.36. What is the difference between the Balance of Payment (as % of service exports) of 2005 and Balance of Payment (as % of service exports) of 2007 in Canada?
Offer a terse response. 0.79. What is the difference between the Balance of Payment (as % of service exports) of 2005 and Balance of Payment (as % of service exports) of 2008 in Canada?
Ensure brevity in your answer.  1.09. What is the difference between the Balance of Payment (as % of service exports) of 2006 and Balance of Payment (as % of service exports) of 2007 in Canada?
Your answer should be very brief. 0.44. What is the difference between the Balance of Payment (as % of service exports) in 2006 and Balance of Payment (as % of service exports) in 2008 in Canada?
Keep it short and to the point. 0.74. What is the difference between the Balance of Payment (as % of service exports) in 2007 and Balance of Payment (as % of service exports) in 2008 in Canada?
Provide a short and direct response. 0.3. What is the ratio of the Balance of Payment (as % of service exports) of 2005 in Bolivia to that in Bosnia and Herzegovina?
Offer a terse response. 1.96. What is the ratio of the Balance of Payment (as % of service exports) of 2006 in Bolivia to that in Bosnia and Herzegovina?
Offer a very short reply. 1.43. What is the ratio of the Balance of Payment (as % of service exports) in 2007 in Bolivia to that in Bosnia and Herzegovina?
Provide a succinct answer. 0.74. What is the ratio of the Balance of Payment (as % of service exports) in 2008 in Bolivia to that in Bosnia and Herzegovina?
Your answer should be very brief. 0.62. What is the ratio of the Balance of Payment (as % of service exports) in 2005 in Bolivia to that in Brazil?
Your answer should be very brief. 1.05. What is the ratio of the Balance of Payment (as % of service exports) in 2006 in Bolivia to that in Brazil?
Your response must be concise. 0.88. What is the ratio of the Balance of Payment (as % of service exports) in 2007 in Bolivia to that in Brazil?
Provide a short and direct response. 0.56. What is the ratio of the Balance of Payment (as % of service exports) in 2008 in Bolivia to that in Brazil?
Your response must be concise. 0.48. What is the ratio of the Balance of Payment (as % of service exports) of 2005 in Bolivia to that in Bulgaria?
Give a very brief answer. 0.8. What is the ratio of the Balance of Payment (as % of service exports) in 2006 in Bolivia to that in Bulgaria?
Your response must be concise. 0.54. What is the ratio of the Balance of Payment (as % of service exports) in 2007 in Bolivia to that in Bulgaria?
Offer a terse response. 0.41. What is the ratio of the Balance of Payment (as % of service exports) of 2008 in Bolivia to that in Bulgaria?
Offer a very short reply. 0.38. What is the ratio of the Balance of Payment (as % of service exports) of 2005 in Bolivia to that in Cabo Verde?
Keep it short and to the point. 0.57. What is the ratio of the Balance of Payment (as % of service exports) in 2006 in Bolivia to that in Cabo Verde?
Your response must be concise. 0.51. What is the ratio of the Balance of Payment (as % of service exports) of 2007 in Bolivia to that in Cabo Verde?
Offer a terse response. 0.38. What is the ratio of the Balance of Payment (as % of service exports) in 2008 in Bolivia to that in Cabo Verde?
Provide a short and direct response. 0.29. What is the ratio of the Balance of Payment (as % of service exports) in 2005 in Bolivia to that in Canada?
Make the answer very short. 1.25. What is the ratio of the Balance of Payment (as % of service exports) in 2006 in Bolivia to that in Canada?
Give a very brief answer. 0.95. What is the ratio of the Balance of Payment (as % of service exports) of 2007 in Bolivia to that in Canada?
Offer a terse response. 0.57. What is the ratio of the Balance of Payment (as % of service exports) of 2008 in Bolivia to that in Canada?
Ensure brevity in your answer.  0.52. What is the ratio of the Balance of Payment (as % of service exports) of 2005 in Bosnia and Herzegovina to that in Brazil?
Make the answer very short. 0.53. What is the ratio of the Balance of Payment (as % of service exports) in 2006 in Bosnia and Herzegovina to that in Brazil?
Your answer should be very brief. 0.61. What is the ratio of the Balance of Payment (as % of service exports) of 2007 in Bosnia and Herzegovina to that in Brazil?
Give a very brief answer. 0.75. What is the ratio of the Balance of Payment (as % of service exports) of 2008 in Bosnia and Herzegovina to that in Brazil?
Offer a terse response. 0.77. What is the ratio of the Balance of Payment (as % of service exports) of 2005 in Bosnia and Herzegovina to that in Bulgaria?
Make the answer very short. 0.41. What is the ratio of the Balance of Payment (as % of service exports) of 2006 in Bosnia and Herzegovina to that in Bulgaria?
Offer a very short reply. 0.37. What is the ratio of the Balance of Payment (as % of service exports) of 2007 in Bosnia and Herzegovina to that in Bulgaria?
Give a very brief answer. 0.55. What is the ratio of the Balance of Payment (as % of service exports) in 2008 in Bosnia and Herzegovina to that in Bulgaria?
Give a very brief answer. 0.6. What is the ratio of the Balance of Payment (as % of service exports) in 2005 in Bosnia and Herzegovina to that in Cabo Verde?
Your answer should be very brief. 0.29. What is the ratio of the Balance of Payment (as % of service exports) of 2006 in Bosnia and Herzegovina to that in Cabo Verde?
Your answer should be very brief. 0.36. What is the ratio of the Balance of Payment (as % of service exports) of 2007 in Bosnia and Herzegovina to that in Cabo Verde?
Make the answer very short. 0.51. What is the ratio of the Balance of Payment (as % of service exports) of 2008 in Bosnia and Herzegovina to that in Cabo Verde?
Ensure brevity in your answer.  0.46. What is the ratio of the Balance of Payment (as % of service exports) of 2005 in Bosnia and Herzegovina to that in Canada?
Give a very brief answer. 0.63. What is the ratio of the Balance of Payment (as % of service exports) in 2006 in Bosnia and Herzegovina to that in Canada?
Offer a terse response. 0.66. What is the ratio of the Balance of Payment (as % of service exports) in 2007 in Bosnia and Herzegovina to that in Canada?
Your answer should be very brief. 0.77. What is the ratio of the Balance of Payment (as % of service exports) of 2008 in Bosnia and Herzegovina to that in Canada?
Offer a terse response. 0.83. What is the ratio of the Balance of Payment (as % of service exports) of 2005 in Brazil to that in Bulgaria?
Your answer should be compact. 0.76. What is the ratio of the Balance of Payment (as % of service exports) in 2006 in Brazil to that in Bulgaria?
Your answer should be compact. 0.61. What is the ratio of the Balance of Payment (as % of service exports) in 2007 in Brazil to that in Bulgaria?
Make the answer very short. 0.73. What is the ratio of the Balance of Payment (as % of service exports) of 2008 in Brazil to that in Bulgaria?
Provide a succinct answer. 0.78. What is the ratio of the Balance of Payment (as % of service exports) of 2005 in Brazil to that in Cabo Verde?
Offer a very short reply. 0.55. What is the ratio of the Balance of Payment (as % of service exports) in 2006 in Brazil to that in Cabo Verde?
Your answer should be compact. 0.58. What is the ratio of the Balance of Payment (as % of service exports) of 2007 in Brazil to that in Cabo Verde?
Keep it short and to the point. 0.68. What is the ratio of the Balance of Payment (as % of service exports) in 2008 in Brazil to that in Cabo Verde?
Keep it short and to the point. 0.6. What is the ratio of the Balance of Payment (as % of service exports) in 2005 in Brazil to that in Canada?
Your answer should be compact. 1.19. What is the ratio of the Balance of Payment (as % of service exports) in 2006 in Brazil to that in Canada?
Ensure brevity in your answer.  1.08. What is the ratio of the Balance of Payment (as % of service exports) in 2008 in Brazil to that in Canada?
Ensure brevity in your answer.  1.08. What is the ratio of the Balance of Payment (as % of service exports) in 2005 in Bulgaria to that in Cabo Verde?
Keep it short and to the point. 0.72. What is the ratio of the Balance of Payment (as % of service exports) of 2006 in Bulgaria to that in Cabo Verde?
Make the answer very short. 0.95. What is the ratio of the Balance of Payment (as % of service exports) of 2007 in Bulgaria to that in Cabo Verde?
Offer a terse response. 0.92. What is the ratio of the Balance of Payment (as % of service exports) in 2008 in Bulgaria to that in Cabo Verde?
Provide a short and direct response. 0.77. What is the ratio of the Balance of Payment (as % of service exports) in 2005 in Bulgaria to that in Canada?
Your answer should be very brief. 1.56. What is the ratio of the Balance of Payment (as % of service exports) of 2006 in Bulgaria to that in Canada?
Your response must be concise. 1.76. What is the ratio of the Balance of Payment (as % of service exports) in 2007 in Bulgaria to that in Canada?
Your answer should be very brief. 1.4. What is the ratio of the Balance of Payment (as % of service exports) in 2008 in Bulgaria to that in Canada?
Ensure brevity in your answer.  1.37. What is the ratio of the Balance of Payment (as % of service exports) of 2005 in Cabo Verde to that in Canada?
Your answer should be very brief. 2.17. What is the ratio of the Balance of Payment (as % of service exports) of 2006 in Cabo Verde to that in Canada?
Your response must be concise. 1.85. What is the ratio of the Balance of Payment (as % of service exports) in 2007 in Cabo Verde to that in Canada?
Offer a very short reply. 1.52. What is the ratio of the Balance of Payment (as % of service exports) of 2008 in Cabo Verde to that in Canada?
Your response must be concise. 1.79. What is the difference between the highest and the second highest Balance of Payment (as % of service exports) in 2005?
Keep it short and to the point. 10.8. What is the difference between the highest and the second highest Balance of Payment (as % of service exports) of 2006?
Keep it short and to the point. 1.49. What is the difference between the highest and the second highest Balance of Payment (as % of service exports) of 2007?
Your response must be concise. 1.93. What is the difference between the highest and the second highest Balance of Payment (as % of service exports) in 2008?
Provide a succinct answer. 6.85. What is the difference between the highest and the lowest Balance of Payment (as % of service exports) of 2005?
Provide a short and direct response. 27.07. What is the difference between the highest and the lowest Balance of Payment (as % of service exports) of 2006?
Provide a succinct answer. 20.54. What is the difference between the highest and the lowest Balance of Payment (as % of service exports) of 2007?
Keep it short and to the point. 15.9. What is the difference between the highest and the lowest Balance of Payment (as % of service exports) of 2008?
Offer a terse response. 21.02. 